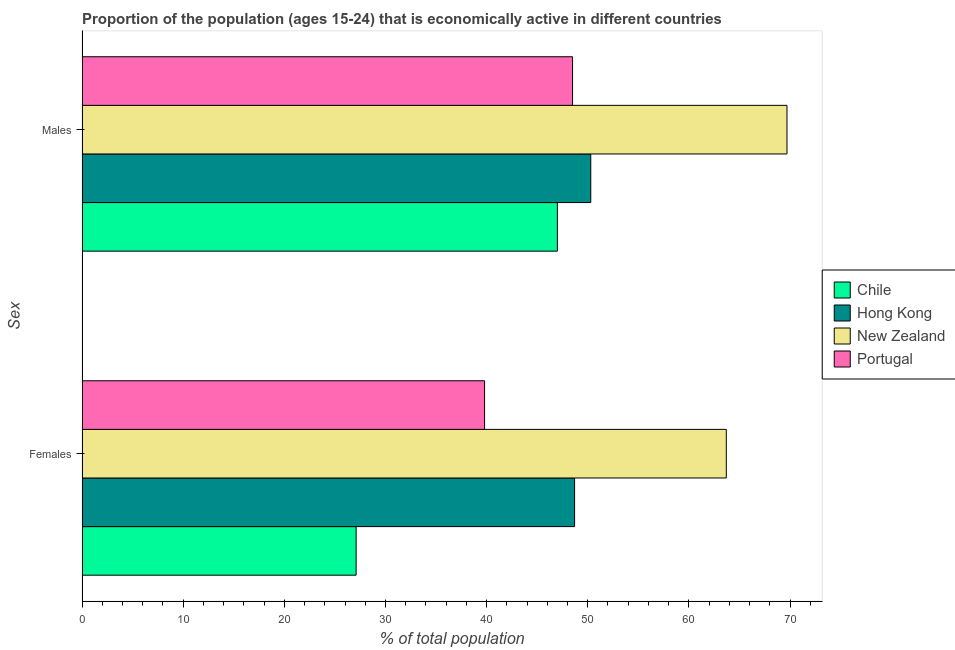How many different coloured bars are there?
Offer a terse response. 4. How many groups of bars are there?
Ensure brevity in your answer.  2. Are the number of bars per tick equal to the number of legend labels?
Keep it short and to the point. Yes. Are the number of bars on each tick of the Y-axis equal?
Keep it short and to the point. Yes. How many bars are there on the 1st tick from the top?
Your response must be concise. 4. What is the label of the 1st group of bars from the top?
Provide a short and direct response. Males. What is the percentage of economically active male population in New Zealand?
Provide a short and direct response. 69.7. Across all countries, what is the maximum percentage of economically active female population?
Give a very brief answer. 63.7. Across all countries, what is the minimum percentage of economically active female population?
Offer a terse response. 27.1. In which country was the percentage of economically active female population maximum?
Your response must be concise. New Zealand. In which country was the percentage of economically active male population minimum?
Ensure brevity in your answer.  Chile. What is the total percentage of economically active female population in the graph?
Ensure brevity in your answer.  179.3. What is the difference between the percentage of economically active female population in Hong Kong and that in New Zealand?
Give a very brief answer. -15. What is the difference between the percentage of economically active male population in Portugal and the percentage of economically active female population in Chile?
Offer a terse response. 21.4. What is the average percentage of economically active male population per country?
Your response must be concise. 53.87. What is the difference between the percentage of economically active female population and percentage of economically active male population in Hong Kong?
Give a very brief answer. -1.6. What is the ratio of the percentage of economically active male population in New Zealand to that in Chile?
Your answer should be compact. 1.48. Is the percentage of economically active female population in Chile less than that in Hong Kong?
Your response must be concise. Yes. In how many countries, is the percentage of economically active male population greater than the average percentage of economically active male population taken over all countries?
Your response must be concise. 1. What does the 2nd bar from the top in Males represents?
Ensure brevity in your answer.  New Zealand. How many countries are there in the graph?
Offer a very short reply. 4. What is the difference between two consecutive major ticks on the X-axis?
Ensure brevity in your answer.  10. Are the values on the major ticks of X-axis written in scientific E-notation?
Provide a short and direct response. No. Does the graph contain any zero values?
Your answer should be compact. No. Where does the legend appear in the graph?
Ensure brevity in your answer.  Center right. What is the title of the graph?
Keep it short and to the point. Proportion of the population (ages 15-24) that is economically active in different countries. What is the label or title of the X-axis?
Provide a short and direct response. % of total population. What is the label or title of the Y-axis?
Ensure brevity in your answer.  Sex. What is the % of total population of Chile in Females?
Your answer should be compact. 27.1. What is the % of total population of Hong Kong in Females?
Your answer should be very brief. 48.7. What is the % of total population of New Zealand in Females?
Provide a short and direct response. 63.7. What is the % of total population of Portugal in Females?
Make the answer very short. 39.8. What is the % of total population in Hong Kong in Males?
Provide a short and direct response. 50.3. What is the % of total population in New Zealand in Males?
Make the answer very short. 69.7. What is the % of total population in Portugal in Males?
Offer a terse response. 48.5. Across all Sex, what is the maximum % of total population of Hong Kong?
Provide a short and direct response. 50.3. Across all Sex, what is the maximum % of total population of New Zealand?
Your answer should be compact. 69.7. Across all Sex, what is the maximum % of total population in Portugal?
Ensure brevity in your answer.  48.5. Across all Sex, what is the minimum % of total population of Chile?
Offer a terse response. 27.1. Across all Sex, what is the minimum % of total population in Hong Kong?
Make the answer very short. 48.7. Across all Sex, what is the minimum % of total population of New Zealand?
Ensure brevity in your answer.  63.7. Across all Sex, what is the minimum % of total population in Portugal?
Your answer should be compact. 39.8. What is the total % of total population in Chile in the graph?
Offer a very short reply. 74.1. What is the total % of total population in Hong Kong in the graph?
Your response must be concise. 99. What is the total % of total population of New Zealand in the graph?
Ensure brevity in your answer.  133.4. What is the total % of total population in Portugal in the graph?
Offer a terse response. 88.3. What is the difference between the % of total population of Chile in Females and that in Males?
Offer a very short reply. -19.9. What is the difference between the % of total population in Hong Kong in Females and that in Males?
Offer a terse response. -1.6. What is the difference between the % of total population in Portugal in Females and that in Males?
Offer a very short reply. -8.7. What is the difference between the % of total population in Chile in Females and the % of total population in Hong Kong in Males?
Your answer should be compact. -23.2. What is the difference between the % of total population in Chile in Females and the % of total population in New Zealand in Males?
Your response must be concise. -42.6. What is the difference between the % of total population of Chile in Females and the % of total population of Portugal in Males?
Keep it short and to the point. -21.4. What is the difference between the % of total population of Hong Kong in Females and the % of total population of New Zealand in Males?
Make the answer very short. -21. What is the difference between the % of total population of New Zealand in Females and the % of total population of Portugal in Males?
Ensure brevity in your answer.  15.2. What is the average % of total population of Chile per Sex?
Make the answer very short. 37.05. What is the average % of total population of Hong Kong per Sex?
Your answer should be compact. 49.5. What is the average % of total population of New Zealand per Sex?
Your answer should be very brief. 66.7. What is the average % of total population in Portugal per Sex?
Provide a short and direct response. 44.15. What is the difference between the % of total population in Chile and % of total population in Hong Kong in Females?
Provide a succinct answer. -21.6. What is the difference between the % of total population in Chile and % of total population in New Zealand in Females?
Your response must be concise. -36.6. What is the difference between the % of total population in New Zealand and % of total population in Portugal in Females?
Offer a very short reply. 23.9. What is the difference between the % of total population in Chile and % of total population in New Zealand in Males?
Your answer should be very brief. -22.7. What is the difference between the % of total population in Hong Kong and % of total population in New Zealand in Males?
Your answer should be very brief. -19.4. What is the difference between the % of total population of Hong Kong and % of total population of Portugal in Males?
Your answer should be very brief. 1.8. What is the difference between the % of total population in New Zealand and % of total population in Portugal in Males?
Make the answer very short. 21.2. What is the ratio of the % of total population in Chile in Females to that in Males?
Give a very brief answer. 0.58. What is the ratio of the % of total population of Hong Kong in Females to that in Males?
Your response must be concise. 0.97. What is the ratio of the % of total population of New Zealand in Females to that in Males?
Offer a terse response. 0.91. What is the ratio of the % of total population in Portugal in Females to that in Males?
Your answer should be compact. 0.82. What is the difference between the highest and the second highest % of total population in Chile?
Your response must be concise. 19.9. What is the difference between the highest and the second highest % of total population of Hong Kong?
Make the answer very short. 1.6. What is the difference between the highest and the lowest % of total population in Chile?
Provide a short and direct response. 19.9. What is the difference between the highest and the lowest % of total population in Hong Kong?
Keep it short and to the point. 1.6. What is the difference between the highest and the lowest % of total population of New Zealand?
Offer a terse response. 6. What is the difference between the highest and the lowest % of total population of Portugal?
Give a very brief answer. 8.7. 